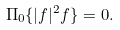Convert formula to latex. <formula><loc_0><loc_0><loc_500><loc_500>\Pi _ { 0 } \{ | f | ^ { 2 } f \} = 0 .</formula> 